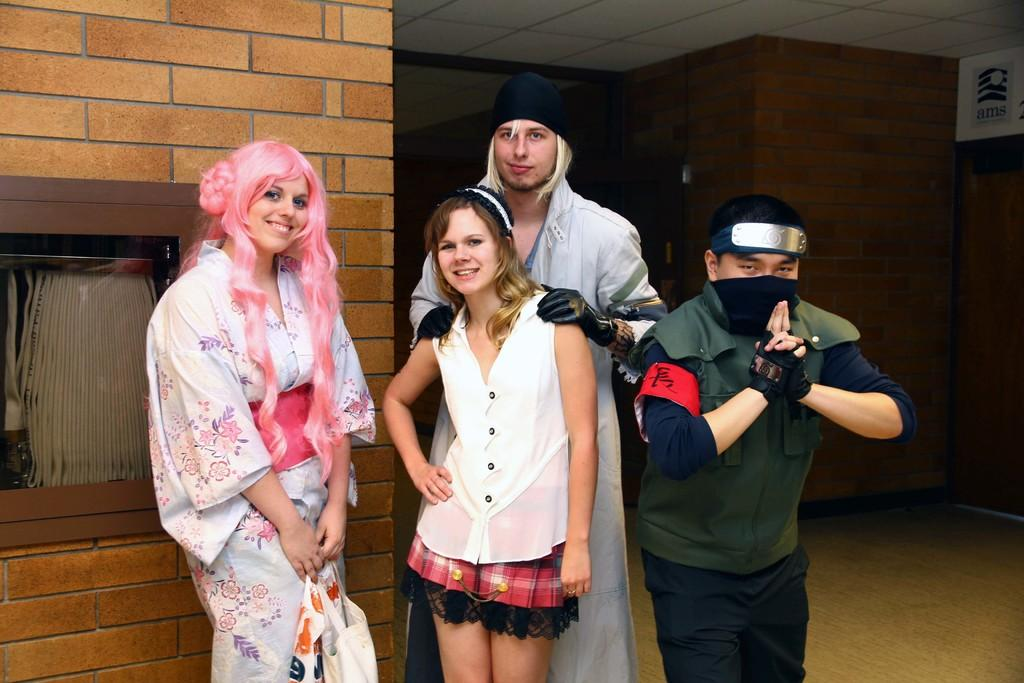How many people are in the foreground of the picture? There are four people in the foreground of the picture, two men and two women. What are the people in the foreground doing? The people in the foreground are smiling and posing for a camera. What can be seen in the background of the picture? There is a brown wall in the background of the picture. What type of sea creatures can be seen swimming in the background of the picture? There are no sea creatures visible in the picture, as it features a brown wall in the background. 